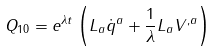Convert formula to latex. <formula><loc_0><loc_0><loc_500><loc_500>Q _ { 1 0 } = e ^ { \lambda t } \left ( L _ { a } \dot { q } ^ { a } + \frac { 1 } { \lambda } L _ { a } V ^ { , a } \right )</formula> 